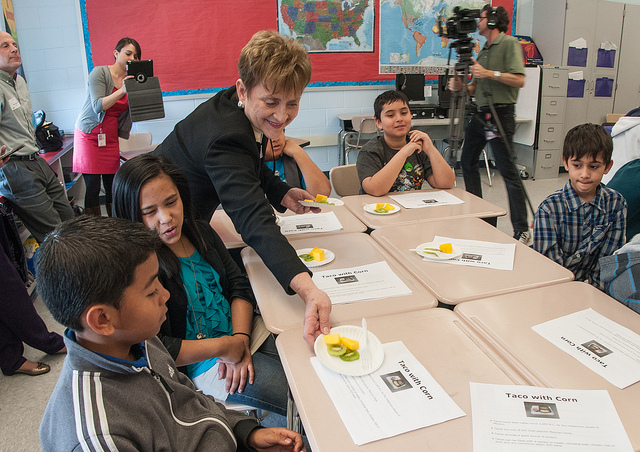Read all the text in this image. Taco Corn COM 